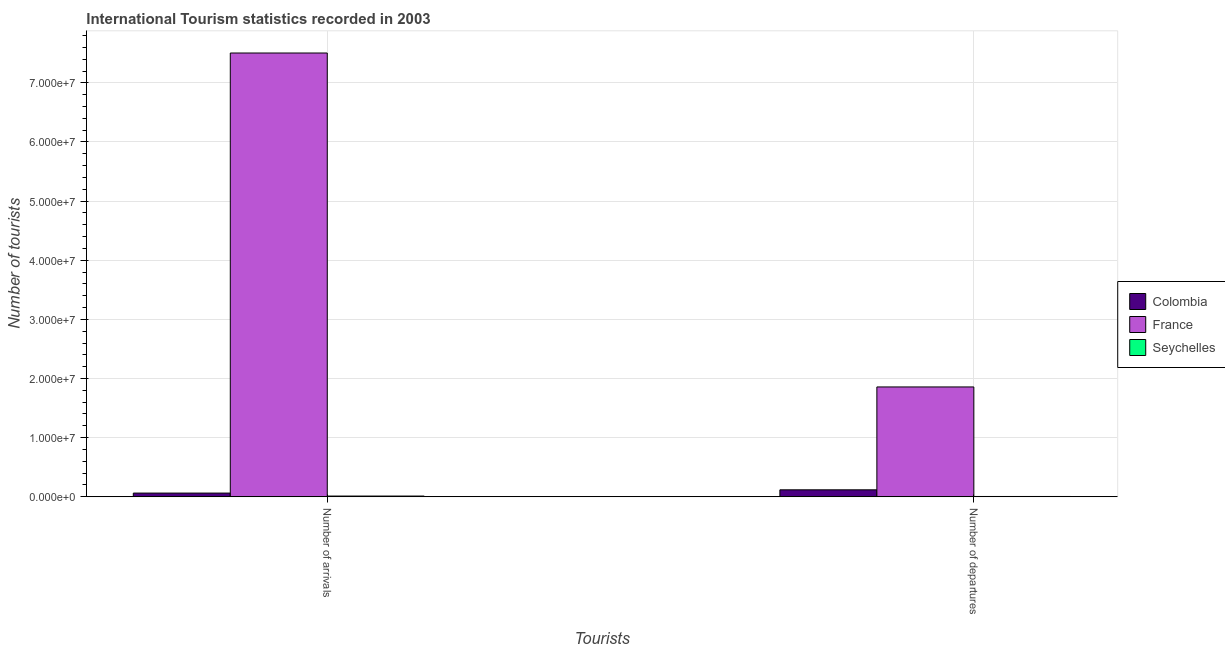How many groups of bars are there?
Provide a short and direct response. 2. How many bars are there on the 1st tick from the left?
Your answer should be compact. 3. How many bars are there on the 1st tick from the right?
Give a very brief answer. 3. What is the label of the 1st group of bars from the left?
Keep it short and to the point. Number of arrivals. What is the number of tourist departures in Seychelles?
Make the answer very short. 5.00e+04. Across all countries, what is the maximum number of tourist arrivals?
Provide a succinct answer. 7.50e+07. Across all countries, what is the minimum number of tourist departures?
Ensure brevity in your answer.  5.00e+04. In which country was the number of tourist departures minimum?
Provide a succinct answer. Seychelles. What is the total number of tourist arrivals in the graph?
Your answer should be very brief. 7.58e+07. What is the difference between the number of tourist departures in Colombia and that in Seychelles?
Keep it short and to the point. 1.13e+06. What is the difference between the number of tourist arrivals in Colombia and the number of tourist departures in Seychelles?
Make the answer very short. 5.75e+05. What is the average number of tourist departures per country?
Offer a terse response. 6.60e+06. What is the difference between the number of tourist departures and number of tourist arrivals in Colombia?
Your answer should be very brief. 5.52e+05. In how many countries, is the number of tourist departures greater than 70000000 ?
Keep it short and to the point. 0. What is the ratio of the number of tourist arrivals in France to that in Colombia?
Provide a succinct answer. 120.08. Is the number of tourist arrivals in Seychelles less than that in Colombia?
Offer a terse response. Yes. What does the 2nd bar from the left in Number of departures represents?
Your response must be concise. France. What does the 3rd bar from the right in Number of departures represents?
Provide a succinct answer. Colombia. How many bars are there?
Give a very brief answer. 6. How many countries are there in the graph?
Give a very brief answer. 3. What is the difference between two consecutive major ticks on the Y-axis?
Offer a terse response. 1.00e+07. Are the values on the major ticks of Y-axis written in scientific E-notation?
Keep it short and to the point. Yes. How are the legend labels stacked?
Your response must be concise. Vertical. What is the title of the graph?
Your answer should be compact. International Tourism statistics recorded in 2003. Does "Oman" appear as one of the legend labels in the graph?
Your response must be concise. No. What is the label or title of the X-axis?
Provide a succinct answer. Tourists. What is the label or title of the Y-axis?
Your answer should be very brief. Number of tourists. What is the Number of tourists in Colombia in Number of arrivals?
Your response must be concise. 6.25e+05. What is the Number of tourists in France in Number of arrivals?
Your answer should be compact. 7.50e+07. What is the Number of tourists of Seychelles in Number of arrivals?
Keep it short and to the point. 1.22e+05. What is the Number of tourists of Colombia in Number of departures?
Your answer should be very brief. 1.18e+06. What is the Number of tourists of France in Number of departures?
Give a very brief answer. 1.86e+07. Across all Tourists, what is the maximum Number of tourists of Colombia?
Your response must be concise. 1.18e+06. Across all Tourists, what is the maximum Number of tourists in France?
Offer a very short reply. 7.50e+07. Across all Tourists, what is the maximum Number of tourists in Seychelles?
Offer a very short reply. 1.22e+05. Across all Tourists, what is the minimum Number of tourists of Colombia?
Your answer should be compact. 6.25e+05. Across all Tourists, what is the minimum Number of tourists in France?
Provide a short and direct response. 1.86e+07. What is the total Number of tourists of Colombia in the graph?
Offer a terse response. 1.80e+06. What is the total Number of tourists in France in the graph?
Give a very brief answer. 9.36e+07. What is the total Number of tourists of Seychelles in the graph?
Keep it short and to the point. 1.72e+05. What is the difference between the Number of tourists of Colombia in Number of arrivals and that in Number of departures?
Offer a very short reply. -5.52e+05. What is the difference between the Number of tourists in France in Number of arrivals and that in Number of departures?
Your response must be concise. 5.65e+07. What is the difference between the Number of tourists of Seychelles in Number of arrivals and that in Number of departures?
Provide a short and direct response. 7.20e+04. What is the difference between the Number of tourists of Colombia in Number of arrivals and the Number of tourists of France in Number of departures?
Keep it short and to the point. -1.80e+07. What is the difference between the Number of tourists in Colombia in Number of arrivals and the Number of tourists in Seychelles in Number of departures?
Ensure brevity in your answer.  5.75e+05. What is the difference between the Number of tourists of France in Number of arrivals and the Number of tourists of Seychelles in Number of departures?
Your response must be concise. 7.50e+07. What is the average Number of tourists in Colombia per Tourists?
Make the answer very short. 9.01e+05. What is the average Number of tourists of France per Tourists?
Your response must be concise. 4.68e+07. What is the average Number of tourists of Seychelles per Tourists?
Your answer should be very brief. 8.60e+04. What is the difference between the Number of tourists of Colombia and Number of tourists of France in Number of arrivals?
Give a very brief answer. -7.44e+07. What is the difference between the Number of tourists in Colombia and Number of tourists in Seychelles in Number of arrivals?
Give a very brief answer. 5.03e+05. What is the difference between the Number of tourists of France and Number of tourists of Seychelles in Number of arrivals?
Give a very brief answer. 7.49e+07. What is the difference between the Number of tourists in Colombia and Number of tourists in France in Number of departures?
Provide a short and direct response. -1.74e+07. What is the difference between the Number of tourists in Colombia and Number of tourists in Seychelles in Number of departures?
Make the answer very short. 1.13e+06. What is the difference between the Number of tourists of France and Number of tourists of Seychelles in Number of departures?
Offer a very short reply. 1.85e+07. What is the ratio of the Number of tourists in Colombia in Number of arrivals to that in Number of departures?
Give a very brief answer. 0.53. What is the ratio of the Number of tourists of France in Number of arrivals to that in Number of departures?
Make the answer very short. 4.04. What is the ratio of the Number of tourists of Seychelles in Number of arrivals to that in Number of departures?
Your response must be concise. 2.44. What is the difference between the highest and the second highest Number of tourists of Colombia?
Your answer should be very brief. 5.52e+05. What is the difference between the highest and the second highest Number of tourists in France?
Keep it short and to the point. 5.65e+07. What is the difference between the highest and the second highest Number of tourists in Seychelles?
Ensure brevity in your answer.  7.20e+04. What is the difference between the highest and the lowest Number of tourists of Colombia?
Make the answer very short. 5.52e+05. What is the difference between the highest and the lowest Number of tourists of France?
Your answer should be very brief. 5.65e+07. What is the difference between the highest and the lowest Number of tourists of Seychelles?
Your response must be concise. 7.20e+04. 